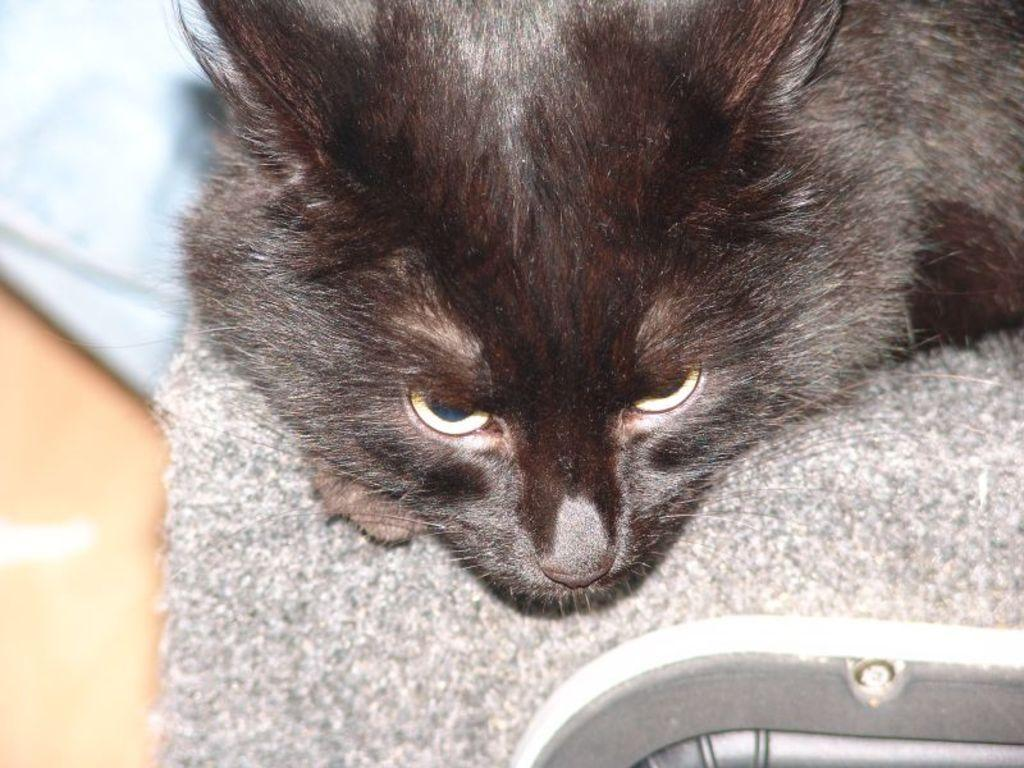What is the main subject of the image? The main subject of the image is a cat. Can you describe the focus of the image? The image is a zoom-in picture of a cat. What type of badge can be seen on the cat's collar in the image? There is no badge or collar present on the cat in the image. 